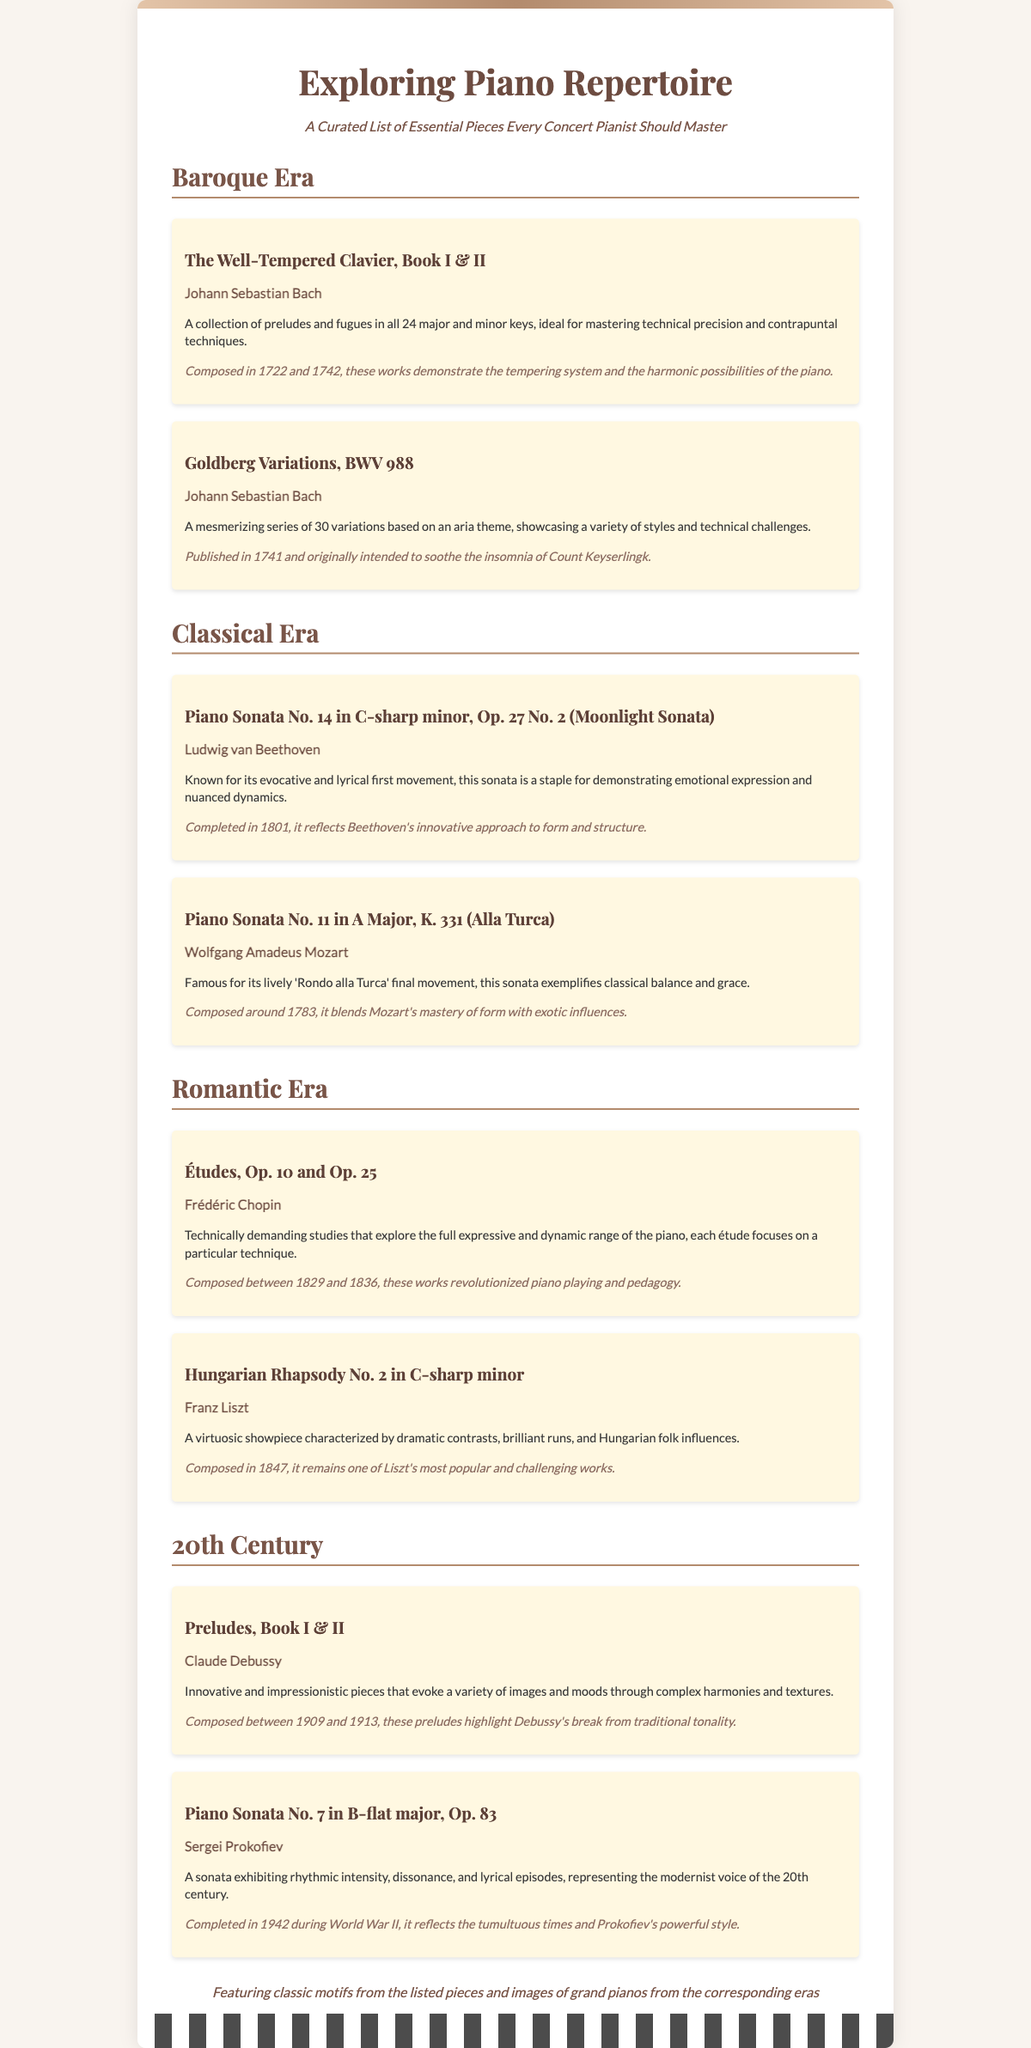What are the titles of the pieces listed under the Baroque Era? The titles are "The Well-Tempered Clavier, Book I & II" and "Goldberg Variations, BWV 988."
Answer: The Well-Tempered Clavier, Book I & II; Goldberg Variations, BWV 988 Who composed the "Moonlight Sonata"? The composer of the "Moonlight Sonata" is Ludwig van Beethoven.
Answer: Ludwig van Beethoven In which year was the "Goldberg Variations" published? The "Goldberg Variations" was published in 1741.
Answer: 1741 How many études did Chopin compose in Op. 10? Chopin composed 12 études in Op. 10.
Answer: 12 What unique style is associated with the pieces in the 20th Century section? The unique style is characterized by impressionism and modernism.
Answer: Impressionism and modernism What is the main theme of the "Goldberg Variations"? The main theme is based on an aria.
Answer: An aria What is the historical context for the "Piano Sonata No. 14 in C-sharp minor"? The historical context reflects Beethoven's innovative approach to form and structure.
Answer: Innovative approach to form and structure Which period does the piece "Hungarian Rhapsody No. 2" belong to? The piece belongs to the Romantic Era.
Answer: Romantic Era What do the illustrations in the document feature? The illustrations feature classic motifs from the listed pieces and images of grand pianos.
Answer: Classic motifs and images of grand pianos 